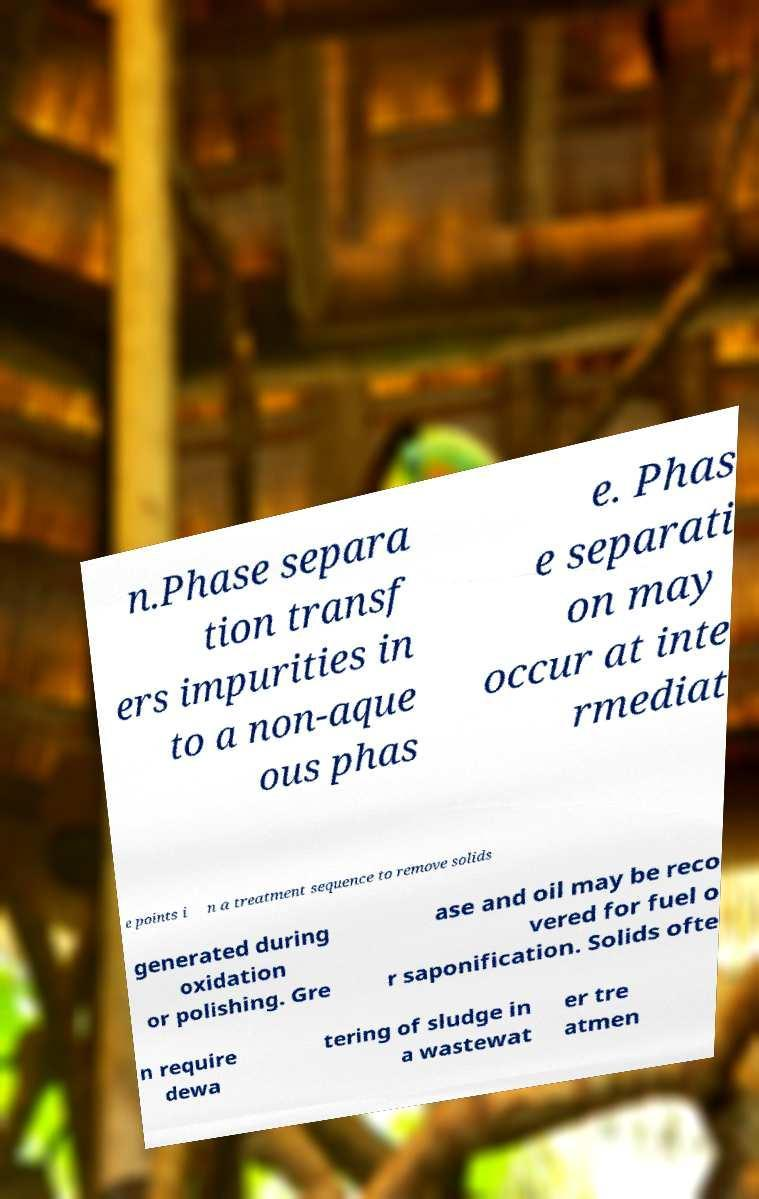What messages or text are displayed in this image? I need them in a readable, typed format. n.Phase separa tion transf ers impurities in to a non-aque ous phas e. Phas e separati on may occur at inte rmediat e points i n a treatment sequence to remove solids generated during oxidation or polishing. Gre ase and oil may be reco vered for fuel o r saponification. Solids ofte n require dewa tering of sludge in a wastewat er tre atmen 